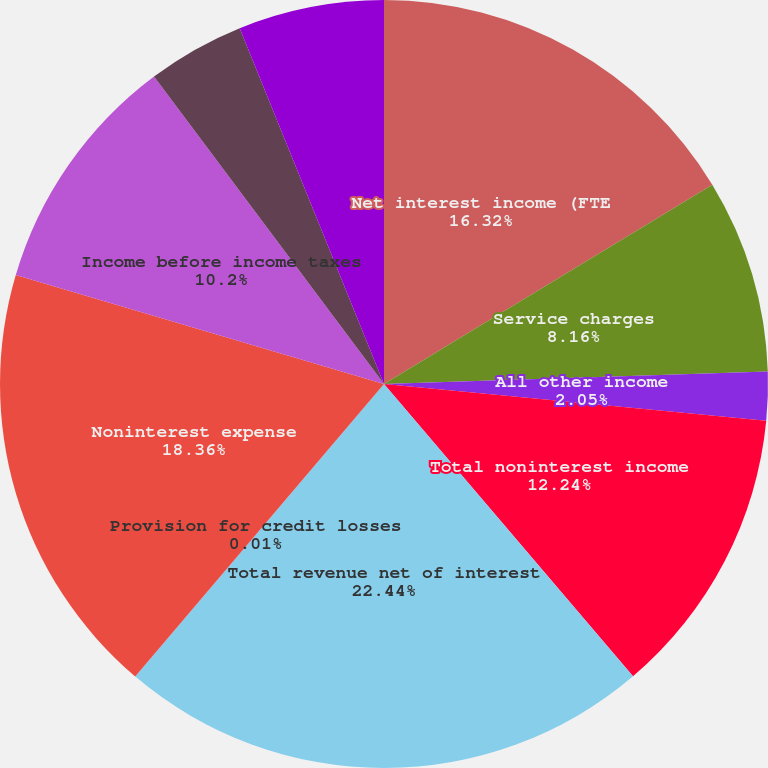Convert chart to OTSL. <chart><loc_0><loc_0><loc_500><loc_500><pie_chart><fcel>Net interest income (FTE<fcel>Service charges<fcel>All other income<fcel>Total noninterest income<fcel>Total revenue net of interest<fcel>Provision for credit losses<fcel>Noninterest expense<fcel>Income before income taxes<fcel>Income tax expense (FTE basis)<fcel>Net income<nl><fcel>16.32%<fcel>8.16%<fcel>2.05%<fcel>12.24%<fcel>22.44%<fcel>0.01%<fcel>18.36%<fcel>10.2%<fcel>4.09%<fcel>6.13%<nl></chart> 